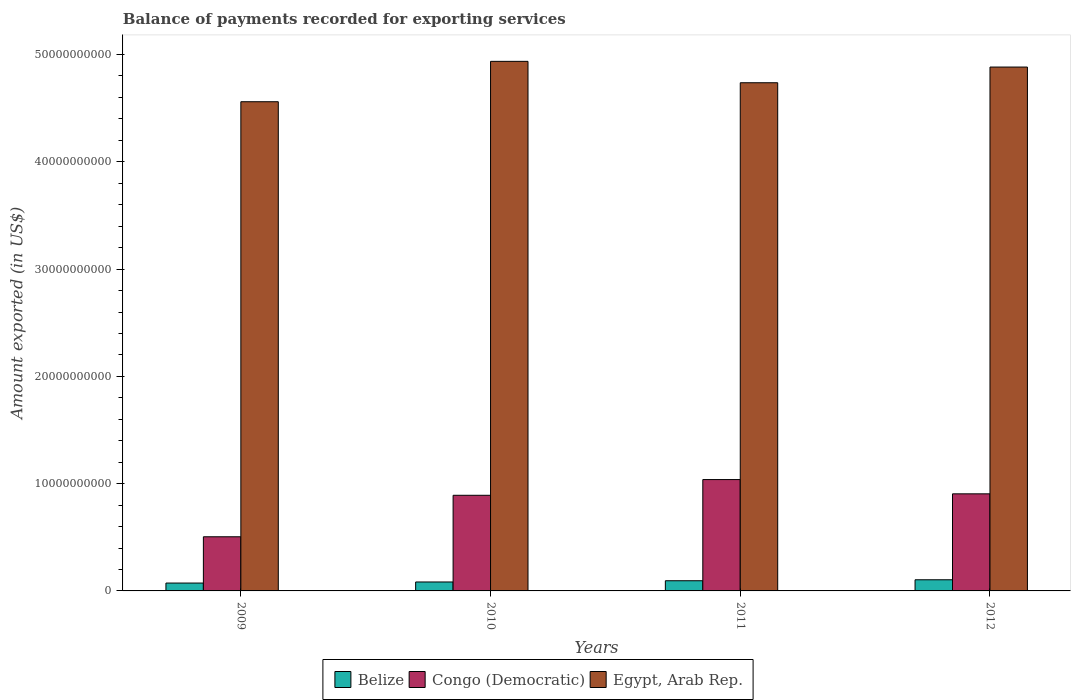How many groups of bars are there?
Provide a short and direct response. 4. How many bars are there on the 4th tick from the right?
Your answer should be very brief. 3. What is the label of the 3rd group of bars from the left?
Make the answer very short. 2011. What is the amount exported in Congo (Democratic) in 2012?
Keep it short and to the point. 9.05e+09. Across all years, what is the maximum amount exported in Congo (Democratic)?
Ensure brevity in your answer.  1.04e+1. Across all years, what is the minimum amount exported in Egypt, Arab Rep.?
Your response must be concise. 4.56e+1. In which year was the amount exported in Egypt, Arab Rep. minimum?
Give a very brief answer. 2009. What is the total amount exported in Egypt, Arab Rep. in the graph?
Give a very brief answer. 1.91e+11. What is the difference between the amount exported in Egypt, Arab Rep. in 2009 and that in 2012?
Provide a short and direct response. -3.23e+09. What is the difference between the amount exported in Congo (Democratic) in 2010 and the amount exported in Egypt, Arab Rep. in 2009?
Give a very brief answer. -3.67e+1. What is the average amount exported in Congo (Democratic) per year?
Give a very brief answer. 8.35e+09. In the year 2009, what is the difference between the amount exported in Congo (Democratic) and amount exported in Egypt, Arab Rep.?
Your answer should be very brief. -4.06e+1. In how many years, is the amount exported in Belize greater than 6000000000 US$?
Offer a very short reply. 0. What is the ratio of the amount exported in Egypt, Arab Rep. in 2010 to that in 2012?
Your answer should be very brief. 1.01. What is the difference between the highest and the second highest amount exported in Congo (Democratic)?
Give a very brief answer. 1.33e+09. What is the difference between the highest and the lowest amount exported in Congo (Democratic)?
Your answer should be very brief. 5.33e+09. In how many years, is the amount exported in Congo (Democratic) greater than the average amount exported in Congo (Democratic) taken over all years?
Provide a short and direct response. 3. Is the sum of the amount exported in Belize in 2009 and 2010 greater than the maximum amount exported in Congo (Democratic) across all years?
Give a very brief answer. No. What does the 1st bar from the left in 2009 represents?
Provide a short and direct response. Belize. What does the 3rd bar from the right in 2012 represents?
Offer a terse response. Belize. Are all the bars in the graph horizontal?
Your answer should be compact. No. Does the graph contain grids?
Provide a short and direct response. No. Where does the legend appear in the graph?
Provide a short and direct response. Bottom center. How are the legend labels stacked?
Offer a very short reply. Horizontal. What is the title of the graph?
Your answer should be compact. Balance of payments recorded for exporting services. What is the label or title of the Y-axis?
Provide a succinct answer. Amount exported (in US$). What is the Amount exported (in US$) in Belize in 2009?
Keep it short and to the point. 7.33e+08. What is the Amount exported (in US$) of Congo (Democratic) in 2009?
Provide a short and direct response. 5.05e+09. What is the Amount exported (in US$) in Egypt, Arab Rep. in 2009?
Your response must be concise. 4.56e+1. What is the Amount exported (in US$) in Belize in 2010?
Offer a very short reply. 8.34e+08. What is the Amount exported (in US$) in Congo (Democratic) in 2010?
Make the answer very short. 8.91e+09. What is the Amount exported (in US$) of Egypt, Arab Rep. in 2010?
Provide a short and direct response. 4.94e+1. What is the Amount exported (in US$) in Belize in 2011?
Your response must be concise. 9.49e+08. What is the Amount exported (in US$) in Congo (Democratic) in 2011?
Give a very brief answer. 1.04e+1. What is the Amount exported (in US$) in Egypt, Arab Rep. in 2011?
Your answer should be compact. 4.74e+1. What is the Amount exported (in US$) in Belize in 2012?
Your answer should be very brief. 1.04e+09. What is the Amount exported (in US$) of Congo (Democratic) in 2012?
Provide a succinct answer. 9.05e+09. What is the Amount exported (in US$) of Egypt, Arab Rep. in 2012?
Provide a short and direct response. 4.88e+1. Across all years, what is the maximum Amount exported (in US$) in Belize?
Ensure brevity in your answer.  1.04e+09. Across all years, what is the maximum Amount exported (in US$) in Congo (Democratic)?
Make the answer very short. 1.04e+1. Across all years, what is the maximum Amount exported (in US$) in Egypt, Arab Rep.?
Your response must be concise. 4.94e+1. Across all years, what is the minimum Amount exported (in US$) of Belize?
Offer a very short reply. 7.33e+08. Across all years, what is the minimum Amount exported (in US$) of Congo (Democratic)?
Your answer should be very brief. 5.05e+09. Across all years, what is the minimum Amount exported (in US$) of Egypt, Arab Rep.?
Provide a succinct answer. 4.56e+1. What is the total Amount exported (in US$) in Belize in the graph?
Provide a short and direct response. 3.55e+09. What is the total Amount exported (in US$) of Congo (Democratic) in the graph?
Offer a terse response. 3.34e+1. What is the total Amount exported (in US$) in Egypt, Arab Rep. in the graph?
Make the answer very short. 1.91e+11. What is the difference between the Amount exported (in US$) in Belize in 2009 and that in 2010?
Your answer should be compact. -1.01e+08. What is the difference between the Amount exported (in US$) of Congo (Democratic) in 2009 and that in 2010?
Offer a very short reply. -3.87e+09. What is the difference between the Amount exported (in US$) in Egypt, Arab Rep. in 2009 and that in 2010?
Ensure brevity in your answer.  -3.76e+09. What is the difference between the Amount exported (in US$) in Belize in 2009 and that in 2011?
Keep it short and to the point. -2.16e+08. What is the difference between the Amount exported (in US$) in Congo (Democratic) in 2009 and that in 2011?
Your response must be concise. -5.33e+09. What is the difference between the Amount exported (in US$) of Egypt, Arab Rep. in 2009 and that in 2011?
Provide a short and direct response. -1.77e+09. What is the difference between the Amount exported (in US$) in Belize in 2009 and that in 2012?
Keep it short and to the point. -3.07e+08. What is the difference between the Amount exported (in US$) of Congo (Democratic) in 2009 and that in 2012?
Your response must be concise. -4.00e+09. What is the difference between the Amount exported (in US$) in Egypt, Arab Rep. in 2009 and that in 2012?
Make the answer very short. -3.23e+09. What is the difference between the Amount exported (in US$) of Belize in 2010 and that in 2011?
Offer a terse response. -1.14e+08. What is the difference between the Amount exported (in US$) in Congo (Democratic) in 2010 and that in 2011?
Make the answer very short. -1.46e+09. What is the difference between the Amount exported (in US$) of Egypt, Arab Rep. in 2010 and that in 2011?
Give a very brief answer. 1.99e+09. What is the difference between the Amount exported (in US$) in Belize in 2010 and that in 2012?
Keep it short and to the point. -2.05e+08. What is the difference between the Amount exported (in US$) of Congo (Democratic) in 2010 and that in 2012?
Make the answer very short. -1.35e+08. What is the difference between the Amount exported (in US$) in Egypt, Arab Rep. in 2010 and that in 2012?
Offer a terse response. 5.31e+08. What is the difference between the Amount exported (in US$) in Belize in 2011 and that in 2012?
Your answer should be very brief. -9.10e+07. What is the difference between the Amount exported (in US$) in Congo (Democratic) in 2011 and that in 2012?
Offer a terse response. 1.33e+09. What is the difference between the Amount exported (in US$) in Egypt, Arab Rep. in 2011 and that in 2012?
Your answer should be very brief. -1.46e+09. What is the difference between the Amount exported (in US$) in Belize in 2009 and the Amount exported (in US$) in Congo (Democratic) in 2010?
Your answer should be compact. -8.18e+09. What is the difference between the Amount exported (in US$) of Belize in 2009 and the Amount exported (in US$) of Egypt, Arab Rep. in 2010?
Your response must be concise. -4.86e+1. What is the difference between the Amount exported (in US$) in Congo (Democratic) in 2009 and the Amount exported (in US$) in Egypt, Arab Rep. in 2010?
Offer a terse response. -4.43e+1. What is the difference between the Amount exported (in US$) in Belize in 2009 and the Amount exported (in US$) in Congo (Democratic) in 2011?
Make the answer very short. -9.65e+09. What is the difference between the Amount exported (in US$) in Belize in 2009 and the Amount exported (in US$) in Egypt, Arab Rep. in 2011?
Give a very brief answer. -4.66e+1. What is the difference between the Amount exported (in US$) of Congo (Democratic) in 2009 and the Amount exported (in US$) of Egypt, Arab Rep. in 2011?
Keep it short and to the point. -4.23e+1. What is the difference between the Amount exported (in US$) in Belize in 2009 and the Amount exported (in US$) in Congo (Democratic) in 2012?
Offer a terse response. -8.32e+09. What is the difference between the Amount exported (in US$) in Belize in 2009 and the Amount exported (in US$) in Egypt, Arab Rep. in 2012?
Offer a terse response. -4.81e+1. What is the difference between the Amount exported (in US$) of Congo (Democratic) in 2009 and the Amount exported (in US$) of Egypt, Arab Rep. in 2012?
Your answer should be compact. -4.38e+1. What is the difference between the Amount exported (in US$) in Belize in 2010 and the Amount exported (in US$) in Congo (Democratic) in 2011?
Give a very brief answer. -9.55e+09. What is the difference between the Amount exported (in US$) of Belize in 2010 and the Amount exported (in US$) of Egypt, Arab Rep. in 2011?
Ensure brevity in your answer.  -4.65e+1. What is the difference between the Amount exported (in US$) of Congo (Democratic) in 2010 and the Amount exported (in US$) of Egypt, Arab Rep. in 2011?
Provide a short and direct response. -3.85e+1. What is the difference between the Amount exported (in US$) in Belize in 2010 and the Amount exported (in US$) in Congo (Democratic) in 2012?
Keep it short and to the point. -8.22e+09. What is the difference between the Amount exported (in US$) in Belize in 2010 and the Amount exported (in US$) in Egypt, Arab Rep. in 2012?
Ensure brevity in your answer.  -4.80e+1. What is the difference between the Amount exported (in US$) of Congo (Democratic) in 2010 and the Amount exported (in US$) of Egypt, Arab Rep. in 2012?
Your answer should be very brief. -3.99e+1. What is the difference between the Amount exported (in US$) of Belize in 2011 and the Amount exported (in US$) of Congo (Democratic) in 2012?
Your answer should be compact. -8.10e+09. What is the difference between the Amount exported (in US$) in Belize in 2011 and the Amount exported (in US$) in Egypt, Arab Rep. in 2012?
Offer a very short reply. -4.79e+1. What is the difference between the Amount exported (in US$) of Congo (Democratic) in 2011 and the Amount exported (in US$) of Egypt, Arab Rep. in 2012?
Your response must be concise. -3.85e+1. What is the average Amount exported (in US$) of Belize per year?
Your answer should be compact. 8.89e+08. What is the average Amount exported (in US$) in Congo (Democratic) per year?
Your response must be concise. 8.35e+09. What is the average Amount exported (in US$) in Egypt, Arab Rep. per year?
Offer a terse response. 4.78e+1. In the year 2009, what is the difference between the Amount exported (in US$) in Belize and Amount exported (in US$) in Congo (Democratic)?
Keep it short and to the point. -4.31e+09. In the year 2009, what is the difference between the Amount exported (in US$) of Belize and Amount exported (in US$) of Egypt, Arab Rep.?
Ensure brevity in your answer.  -4.49e+1. In the year 2009, what is the difference between the Amount exported (in US$) of Congo (Democratic) and Amount exported (in US$) of Egypt, Arab Rep.?
Make the answer very short. -4.06e+1. In the year 2010, what is the difference between the Amount exported (in US$) of Belize and Amount exported (in US$) of Congo (Democratic)?
Your answer should be very brief. -8.08e+09. In the year 2010, what is the difference between the Amount exported (in US$) of Belize and Amount exported (in US$) of Egypt, Arab Rep.?
Offer a very short reply. -4.85e+1. In the year 2010, what is the difference between the Amount exported (in US$) of Congo (Democratic) and Amount exported (in US$) of Egypt, Arab Rep.?
Provide a short and direct response. -4.05e+1. In the year 2011, what is the difference between the Amount exported (in US$) in Belize and Amount exported (in US$) in Congo (Democratic)?
Keep it short and to the point. -9.43e+09. In the year 2011, what is the difference between the Amount exported (in US$) of Belize and Amount exported (in US$) of Egypt, Arab Rep.?
Your answer should be compact. -4.64e+1. In the year 2011, what is the difference between the Amount exported (in US$) in Congo (Democratic) and Amount exported (in US$) in Egypt, Arab Rep.?
Make the answer very short. -3.70e+1. In the year 2012, what is the difference between the Amount exported (in US$) in Belize and Amount exported (in US$) in Congo (Democratic)?
Provide a short and direct response. -8.01e+09. In the year 2012, what is the difference between the Amount exported (in US$) of Belize and Amount exported (in US$) of Egypt, Arab Rep.?
Your answer should be compact. -4.78e+1. In the year 2012, what is the difference between the Amount exported (in US$) in Congo (Democratic) and Amount exported (in US$) in Egypt, Arab Rep.?
Give a very brief answer. -3.98e+1. What is the ratio of the Amount exported (in US$) in Belize in 2009 to that in 2010?
Provide a succinct answer. 0.88. What is the ratio of the Amount exported (in US$) of Congo (Democratic) in 2009 to that in 2010?
Ensure brevity in your answer.  0.57. What is the ratio of the Amount exported (in US$) of Egypt, Arab Rep. in 2009 to that in 2010?
Your response must be concise. 0.92. What is the ratio of the Amount exported (in US$) of Belize in 2009 to that in 2011?
Ensure brevity in your answer.  0.77. What is the ratio of the Amount exported (in US$) in Congo (Democratic) in 2009 to that in 2011?
Make the answer very short. 0.49. What is the ratio of the Amount exported (in US$) in Egypt, Arab Rep. in 2009 to that in 2011?
Offer a terse response. 0.96. What is the ratio of the Amount exported (in US$) in Belize in 2009 to that in 2012?
Provide a succinct answer. 0.7. What is the ratio of the Amount exported (in US$) of Congo (Democratic) in 2009 to that in 2012?
Provide a succinct answer. 0.56. What is the ratio of the Amount exported (in US$) in Egypt, Arab Rep. in 2009 to that in 2012?
Provide a short and direct response. 0.93. What is the ratio of the Amount exported (in US$) of Belize in 2010 to that in 2011?
Offer a very short reply. 0.88. What is the ratio of the Amount exported (in US$) in Congo (Democratic) in 2010 to that in 2011?
Ensure brevity in your answer.  0.86. What is the ratio of the Amount exported (in US$) of Egypt, Arab Rep. in 2010 to that in 2011?
Offer a very short reply. 1.04. What is the ratio of the Amount exported (in US$) of Belize in 2010 to that in 2012?
Give a very brief answer. 0.8. What is the ratio of the Amount exported (in US$) in Congo (Democratic) in 2010 to that in 2012?
Ensure brevity in your answer.  0.99. What is the ratio of the Amount exported (in US$) in Egypt, Arab Rep. in 2010 to that in 2012?
Provide a short and direct response. 1.01. What is the ratio of the Amount exported (in US$) of Belize in 2011 to that in 2012?
Your answer should be very brief. 0.91. What is the ratio of the Amount exported (in US$) of Congo (Democratic) in 2011 to that in 2012?
Your answer should be compact. 1.15. What is the difference between the highest and the second highest Amount exported (in US$) of Belize?
Ensure brevity in your answer.  9.10e+07. What is the difference between the highest and the second highest Amount exported (in US$) of Congo (Democratic)?
Offer a terse response. 1.33e+09. What is the difference between the highest and the second highest Amount exported (in US$) of Egypt, Arab Rep.?
Make the answer very short. 5.31e+08. What is the difference between the highest and the lowest Amount exported (in US$) in Belize?
Your response must be concise. 3.07e+08. What is the difference between the highest and the lowest Amount exported (in US$) in Congo (Democratic)?
Give a very brief answer. 5.33e+09. What is the difference between the highest and the lowest Amount exported (in US$) of Egypt, Arab Rep.?
Offer a terse response. 3.76e+09. 